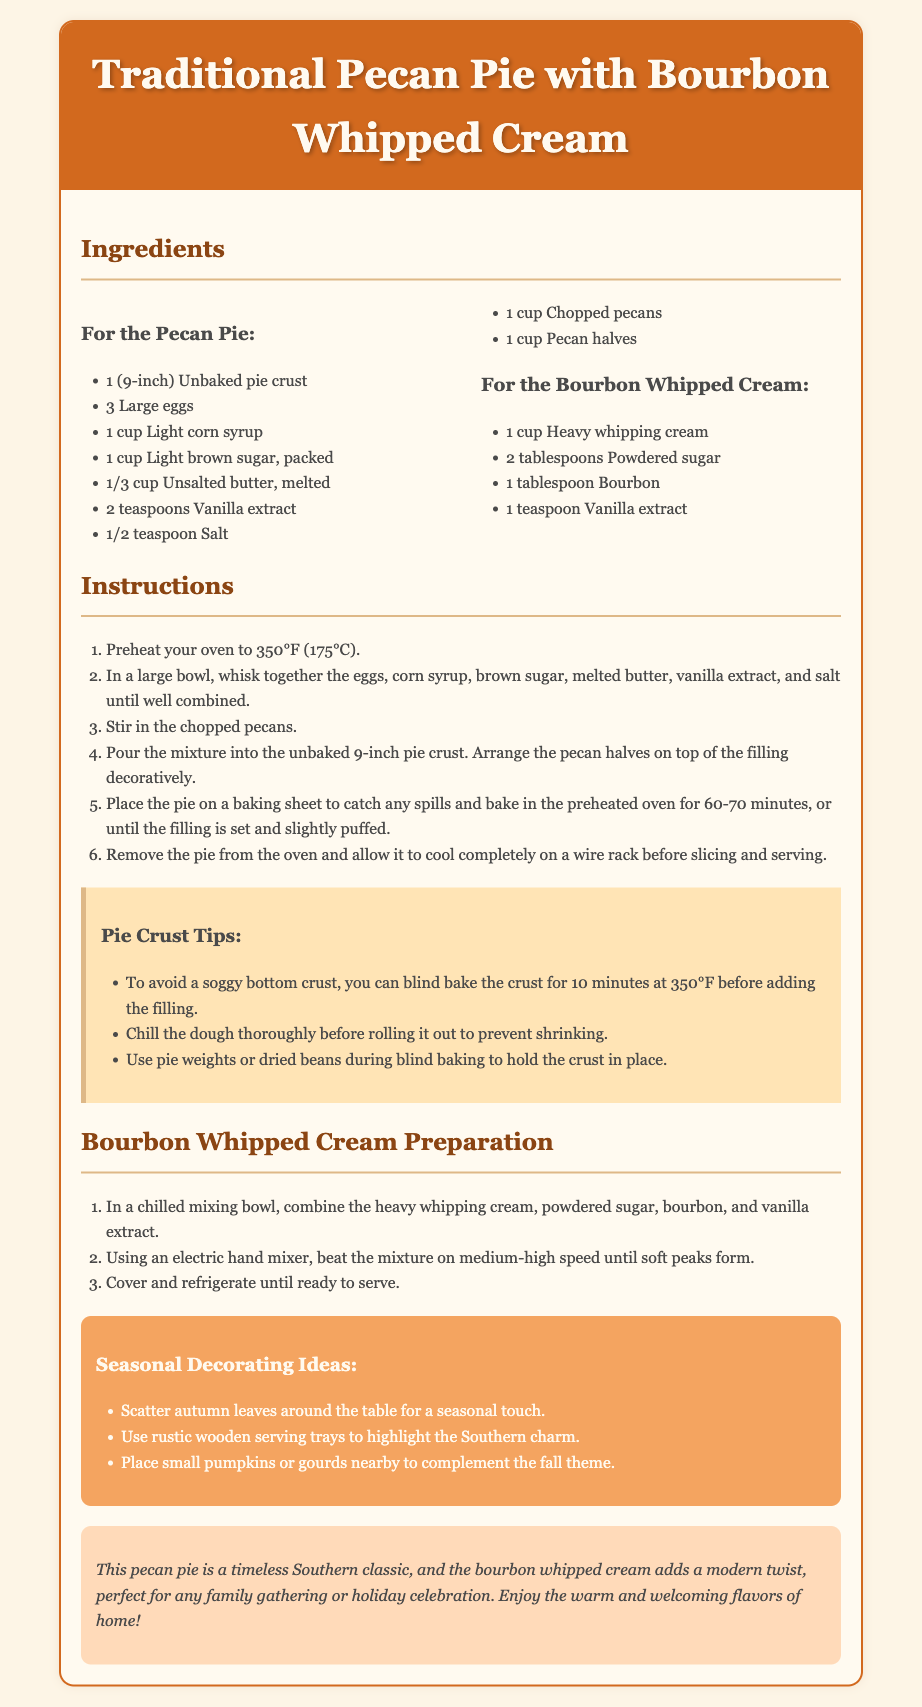What is the cooking temperature for the pie? The cooking temperature for the pie is specified in the instructions section of the document.
Answer: 350°F How long should the pie bake? The document states the baking duration in the instructions section.
Answer: 60-70 minutes What type of pie crust is used? The ingredients section mentions the specific type of pie crust required for the recipe.
Answer: Unbaked pie crust What is one of the main ingredients in the Bourbon Whipped Cream? The ingredients section lists components for Bourbon Whipped Cream.
Answer: Heavy whipping cream What should you do to avoid a soggy bottom crust? The tip box provides advice on preventing a soggy bottom crust.
Answer: Blind bake the crust How many large eggs are needed for the pie? The ingredients list specifies the number of large eggs required in the preparation.
Answer: 3 Which seasonal decorating idea involves table accessories? The decoration ideas include various suggestions for seasonal touches on the table, one of which involves table accessories.
Answer: Autumn leaves What is the final wait step before serving the Bourbon Whipped Cream? The preparation steps for the Bourbon Whipped Cream specify what to do after mixing.
Answer: Cover and refrigerate 